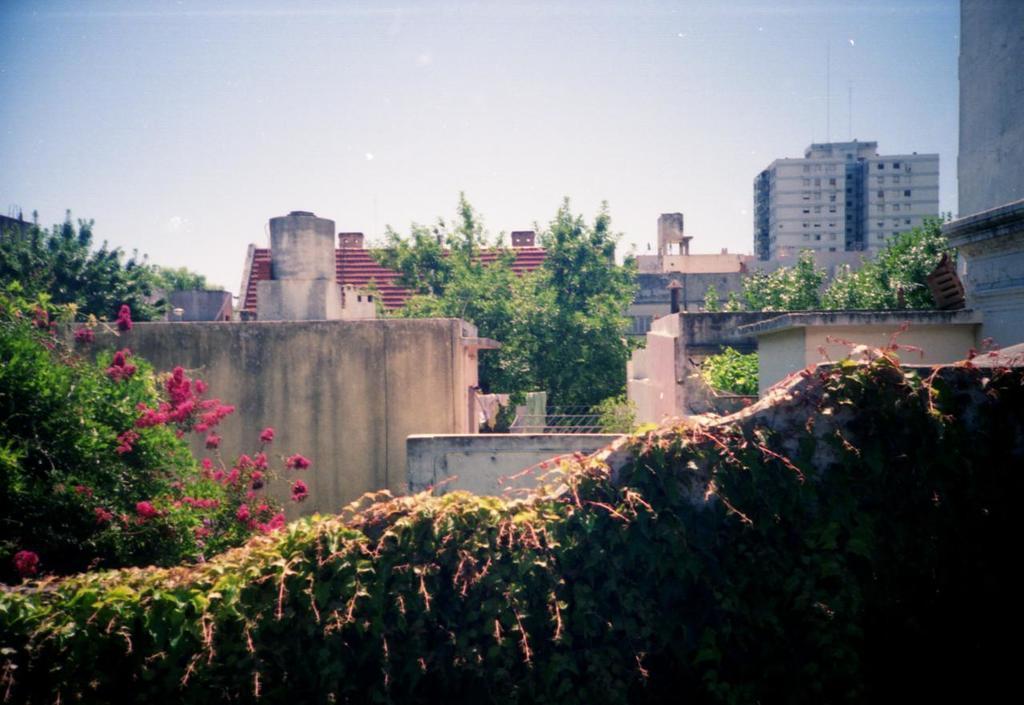How would you summarize this image in a sentence or two? In this image we can see buildings, grill, clothes, creepers, trees, plants and sky. 